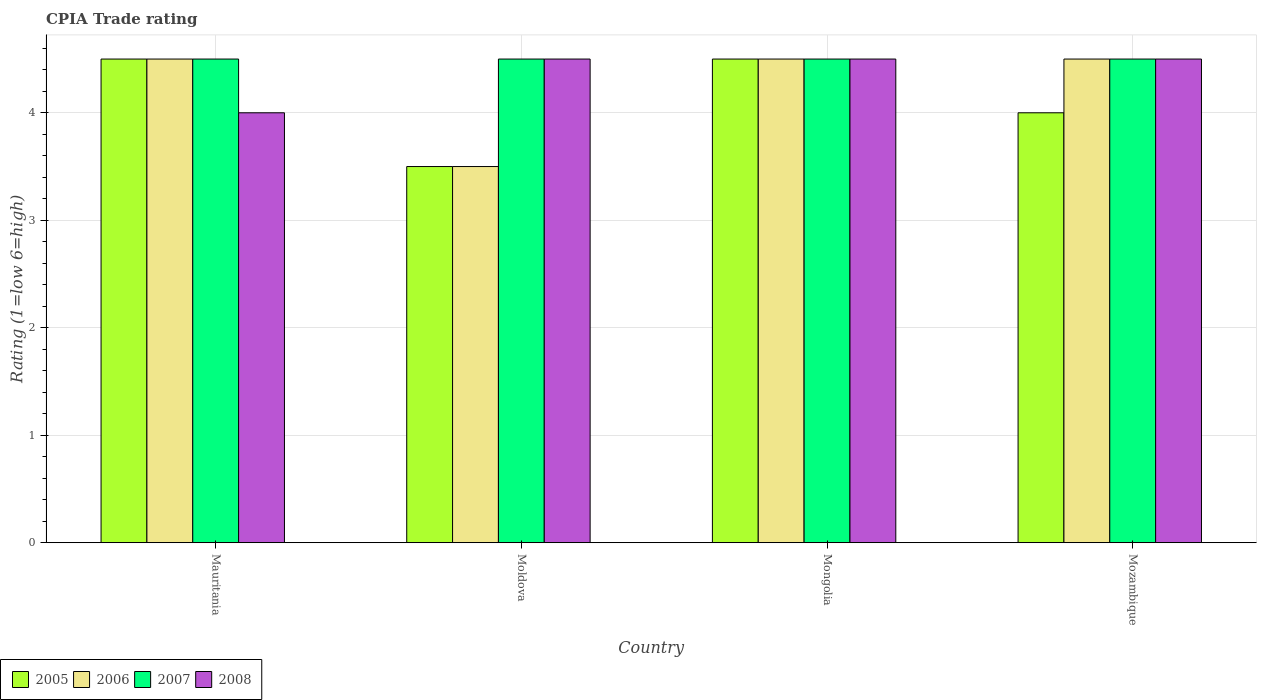Are the number of bars per tick equal to the number of legend labels?
Provide a short and direct response. Yes. How many bars are there on the 4th tick from the right?
Your answer should be very brief. 4. What is the label of the 3rd group of bars from the left?
Ensure brevity in your answer.  Mongolia. Across all countries, what is the maximum CPIA rating in 2007?
Keep it short and to the point. 4.5. Across all countries, what is the minimum CPIA rating in 2007?
Your answer should be compact. 4.5. In which country was the CPIA rating in 2005 maximum?
Keep it short and to the point. Mauritania. In which country was the CPIA rating in 2005 minimum?
Provide a short and direct response. Moldova. What is the total CPIA rating in 2007 in the graph?
Make the answer very short. 18. What is the difference between the CPIA rating in 2006 in Mozambique and the CPIA rating in 2008 in Mongolia?
Your answer should be very brief. 0. What is the average CPIA rating in 2005 per country?
Your answer should be compact. 4.12. In how many countries, is the CPIA rating in 2007 greater than 2.8?
Offer a very short reply. 4. What is the ratio of the CPIA rating in 2006 in Moldova to that in Mozambique?
Your answer should be very brief. 0.78. Is the difference between the CPIA rating in 2008 in Mauritania and Moldova greater than the difference between the CPIA rating in 2007 in Mauritania and Moldova?
Ensure brevity in your answer.  No. Is it the case that in every country, the sum of the CPIA rating in 2005 and CPIA rating in 2008 is greater than the sum of CPIA rating in 2006 and CPIA rating in 2007?
Provide a short and direct response. No. What does the 4th bar from the left in Mauritania represents?
Offer a very short reply. 2008. What does the 4th bar from the right in Mozambique represents?
Your answer should be very brief. 2005. How many bars are there?
Your answer should be very brief. 16. Are all the bars in the graph horizontal?
Provide a succinct answer. No. What is the difference between two consecutive major ticks on the Y-axis?
Offer a very short reply. 1. Does the graph contain grids?
Give a very brief answer. Yes. Where does the legend appear in the graph?
Make the answer very short. Bottom left. What is the title of the graph?
Provide a short and direct response. CPIA Trade rating. What is the label or title of the Y-axis?
Keep it short and to the point. Rating (1=low 6=high). What is the Rating (1=low 6=high) in 2008 in Mauritania?
Give a very brief answer. 4. What is the Rating (1=low 6=high) in 2006 in Moldova?
Offer a very short reply. 3.5. What is the Rating (1=low 6=high) of 2007 in Moldova?
Your answer should be compact. 4.5. What is the Rating (1=low 6=high) of 2008 in Mongolia?
Your response must be concise. 4.5. Across all countries, what is the maximum Rating (1=low 6=high) of 2005?
Ensure brevity in your answer.  4.5. Across all countries, what is the maximum Rating (1=low 6=high) of 2008?
Offer a terse response. 4.5. What is the total Rating (1=low 6=high) in 2005 in the graph?
Offer a very short reply. 16.5. What is the total Rating (1=low 6=high) of 2006 in the graph?
Keep it short and to the point. 17. What is the total Rating (1=low 6=high) in 2007 in the graph?
Make the answer very short. 18. What is the difference between the Rating (1=low 6=high) in 2005 in Mauritania and that in Moldova?
Ensure brevity in your answer.  1. What is the difference between the Rating (1=low 6=high) in 2006 in Mauritania and that in Moldova?
Offer a very short reply. 1. What is the difference between the Rating (1=low 6=high) of 2005 in Mauritania and that in Mongolia?
Keep it short and to the point. 0. What is the difference between the Rating (1=low 6=high) of 2006 in Mauritania and that in Mongolia?
Provide a succinct answer. 0. What is the difference between the Rating (1=low 6=high) of 2007 in Mauritania and that in Mongolia?
Your answer should be very brief. 0. What is the difference between the Rating (1=low 6=high) of 2008 in Mauritania and that in Mongolia?
Your answer should be very brief. -0.5. What is the difference between the Rating (1=low 6=high) in 2005 in Mauritania and that in Mozambique?
Your answer should be compact. 0.5. What is the difference between the Rating (1=low 6=high) of 2006 in Mauritania and that in Mozambique?
Your response must be concise. 0. What is the difference between the Rating (1=low 6=high) in 2007 in Mauritania and that in Mozambique?
Make the answer very short. 0. What is the difference between the Rating (1=low 6=high) in 2006 in Moldova and that in Mongolia?
Keep it short and to the point. -1. What is the difference between the Rating (1=low 6=high) in 2005 in Moldova and that in Mozambique?
Offer a very short reply. -0.5. What is the difference between the Rating (1=low 6=high) of 2006 in Moldova and that in Mozambique?
Ensure brevity in your answer.  -1. What is the difference between the Rating (1=low 6=high) of 2005 in Mongolia and that in Mozambique?
Provide a succinct answer. 0.5. What is the difference between the Rating (1=low 6=high) of 2006 in Mongolia and that in Mozambique?
Provide a short and direct response. 0. What is the difference between the Rating (1=low 6=high) in 2008 in Mongolia and that in Mozambique?
Your answer should be very brief. 0. What is the difference between the Rating (1=low 6=high) of 2005 in Mauritania and the Rating (1=low 6=high) of 2006 in Moldova?
Provide a succinct answer. 1. What is the difference between the Rating (1=low 6=high) in 2005 in Mauritania and the Rating (1=low 6=high) in 2007 in Moldova?
Give a very brief answer. 0. What is the difference between the Rating (1=low 6=high) in 2006 in Mauritania and the Rating (1=low 6=high) in 2007 in Moldova?
Provide a succinct answer. 0. What is the difference between the Rating (1=low 6=high) in 2007 in Mauritania and the Rating (1=low 6=high) in 2008 in Moldova?
Your answer should be compact. 0. What is the difference between the Rating (1=low 6=high) in 2005 in Mauritania and the Rating (1=low 6=high) in 2006 in Mongolia?
Provide a short and direct response. 0. What is the difference between the Rating (1=low 6=high) in 2006 in Mauritania and the Rating (1=low 6=high) in 2007 in Mongolia?
Provide a short and direct response. 0. What is the difference between the Rating (1=low 6=high) in 2007 in Mauritania and the Rating (1=low 6=high) in 2008 in Mongolia?
Make the answer very short. 0. What is the difference between the Rating (1=low 6=high) in 2005 in Mauritania and the Rating (1=low 6=high) in 2006 in Mozambique?
Provide a succinct answer. 0. What is the difference between the Rating (1=low 6=high) in 2005 in Mauritania and the Rating (1=low 6=high) in 2007 in Mozambique?
Your answer should be very brief. 0. What is the difference between the Rating (1=low 6=high) in 2005 in Mauritania and the Rating (1=low 6=high) in 2008 in Mozambique?
Your response must be concise. 0. What is the difference between the Rating (1=low 6=high) in 2006 in Mauritania and the Rating (1=low 6=high) in 2007 in Mozambique?
Provide a short and direct response. 0. What is the difference between the Rating (1=low 6=high) of 2006 in Mauritania and the Rating (1=low 6=high) of 2008 in Mozambique?
Offer a terse response. 0. What is the difference between the Rating (1=low 6=high) of 2007 in Mauritania and the Rating (1=low 6=high) of 2008 in Mozambique?
Offer a terse response. 0. What is the difference between the Rating (1=low 6=high) in 2005 in Moldova and the Rating (1=low 6=high) in 2008 in Mongolia?
Offer a terse response. -1. What is the difference between the Rating (1=low 6=high) in 2006 in Moldova and the Rating (1=low 6=high) in 2008 in Mongolia?
Offer a very short reply. -1. What is the difference between the Rating (1=low 6=high) in 2007 in Moldova and the Rating (1=low 6=high) in 2008 in Mongolia?
Offer a very short reply. 0. What is the difference between the Rating (1=low 6=high) in 2005 in Moldova and the Rating (1=low 6=high) in 2006 in Mozambique?
Make the answer very short. -1. What is the difference between the Rating (1=low 6=high) of 2005 in Moldova and the Rating (1=low 6=high) of 2007 in Mozambique?
Ensure brevity in your answer.  -1. What is the difference between the Rating (1=low 6=high) of 2005 in Moldova and the Rating (1=low 6=high) of 2008 in Mozambique?
Provide a short and direct response. -1. What is the difference between the Rating (1=low 6=high) of 2007 in Moldova and the Rating (1=low 6=high) of 2008 in Mozambique?
Ensure brevity in your answer.  0. What is the difference between the Rating (1=low 6=high) of 2005 in Mongolia and the Rating (1=low 6=high) of 2008 in Mozambique?
Give a very brief answer. 0. What is the difference between the Rating (1=low 6=high) of 2006 in Mongolia and the Rating (1=low 6=high) of 2007 in Mozambique?
Your answer should be compact. 0. What is the average Rating (1=low 6=high) of 2005 per country?
Your answer should be very brief. 4.12. What is the average Rating (1=low 6=high) of 2006 per country?
Give a very brief answer. 4.25. What is the average Rating (1=low 6=high) of 2008 per country?
Provide a short and direct response. 4.38. What is the difference between the Rating (1=low 6=high) of 2005 and Rating (1=low 6=high) of 2006 in Mauritania?
Your response must be concise. 0. What is the difference between the Rating (1=low 6=high) of 2005 and Rating (1=low 6=high) of 2007 in Mauritania?
Keep it short and to the point. 0. What is the difference between the Rating (1=low 6=high) in 2005 and Rating (1=low 6=high) in 2008 in Mauritania?
Provide a succinct answer. 0.5. What is the difference between the Rating (1=low 6=high) in 2007 and Rating (1=low 6=high) in 2008 in Mauritania?
Your response must be concise. 0.5. What is the difference between the Rating (1=low 6=high) of 2005 and Rating (1=low 6=high) of 2007 in Moldova?
Ensure brevity in your answer.  -1. What is the difference between the Rating (1=low 6=high) of 2005 and Rating (1=low 6=high) of 2008 in Moldova?
Your response must be concise. -1. What is the difference between the Rating (1=low 6=high) in 2006 and Rating (1=low 6=high) in 2007 in Moldova?
Ensure brevity in your answer.  -1. What is the difference between the Rating (1=low 6=high) of 2007 and Rating (1=low 6=high) of 2008 in Moldova?
Your response must be concise. 0. What is the difference between the Rating (1=low 6=high) of 2005 and Rating (1=low 6=high) of 2008 in Mongolia?
Keep it short and to the point. 0. What is the difference between the Rating (1=low 6=high) of 2006 and Rating (1=low 6=high) of 2007 in Mongolia?
Provide a short and direct response. 0. What is the difference between the Rating (1=low 6=high) in 2007 and Rating (1=low 6=high) in 2008 in Mongolia?
Your response must be concise. 0. What is the difference between the Rating (1=low 6=high) in 2005 and Rating (1=low 6=high) in 2006 in Mozambique?
Provide a succinct answer. -0.5. What is the difference between the Rating (1=low 6=high) in 2005 and Rating (1=low 6=high) in 2008 in Mozambique?
Make the answer very short. -0.5. What is the difference between the Rating (1=low 6=high) in 2006 and Rating (1=low 6=high) in 2007 in Mozambique?
Your response must be concise. 0. What is the ratio of the Rating (1=low 6=high) in 2006 in Mauritania to that in Mongolia?
Make the answer very short. 1. What is the ratio of the Rating (1=low 6=high) of 2007 in Mauritania to that in Mongolia?
Offer a terse response. 1. What is the ratio of the Rating (1=low 6=high) of 2008 in Mauritania to that in Mongolia?
Offer a very short reply. 0.89. What is the ratio of the Rating (1=low 6=high) in 2005 in Mauritania to that in Mozambique?
Keep it short and to the point. 1.12. What is the ratio of the Rating (1=low 6=high) of 2007 in Mauritania to that in Mozambique?
Provide a short and direct response. 1. What is the ratio of the Rating (1=low 6=high) in 2006 in Moldova to that in Mongolia?
Keep it short and to the point. 0.78. What is the ratio of the Rating (1=low 6=high) of 2007 in Moldova to that in Mongolia?
Your answer should be compact. 1. What is the ratio of the Rating (1=low 6=high) of 2008 in Moldova to that in Mongolia?
Give a very brief answer. 1. What is the ratio of the Rating (1=low 6=high) of 2007 in Moldova to that in Mozambique?
Offer a very short reply. 1. What is the ratio of the Rating (1=low 6=high) in 2008 in Moldova to that in Mozambique?
Ensure brevity in your answer.  1. What is the difference between the highest and the second highest Rating (1=low 6=high) in 2005?
Provide a succinct answer. 0. What is the difference between the highest and the lowest Rating (1=low 6=high) in 2007?
Provide a short and direct response. 0. What is the difference between the highest and the lowest Rating (1=low 6=high) of 2008?
Keep it short and to the point. 0.5. 